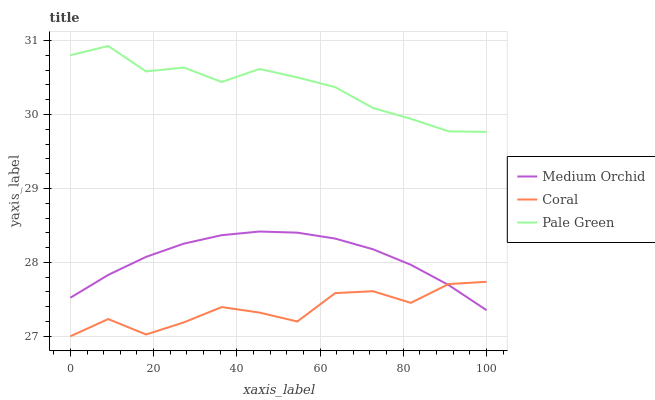Does Coral have the minimum area under the curve?
Answer yes or no. Yes. Does Pale Green have the maximum area under the curve?
Answer yes or no. Yes. Does Medium Orchid have the minimum area under the curve?
Answer yes or no. No. Does Medium Orchid have the maximum area under the curve?
Answer yes or no. No. Is Medium Orchid the smoothest?
Answer yes or no. Yes. Is Coral the roughest?
Answer yes or no. Yes. Is Coral the smoothest?
Answer yes or no. No. Is Medium Orchid the roughest?
Answer yes or no. No. Does Coral have the lowest value?
Answer yes or no. Yes. Does Medium Orchid have the lowest value?
Answer yes or no. No. Does Pale Green have the highest value?
Answer yes or no. Yes. Does Medium Orchid have the highest value?
Answer yes or no. No. Is Coral less than Pale Green?
Answer yes or no. Yes. Is Pale Green greater than Medium Orchid?
Answer yes or no. Yes. Does Coral intersect Medium Orchid?
Answer yes or no. Yes. Is Coral less than Medium Orchid?
Answer yes or no. No. Is Coral greater than Medium Orchid?
Answer yes or no. No. Does Coral intersect Pale Green?
Answer yes or no. No. 